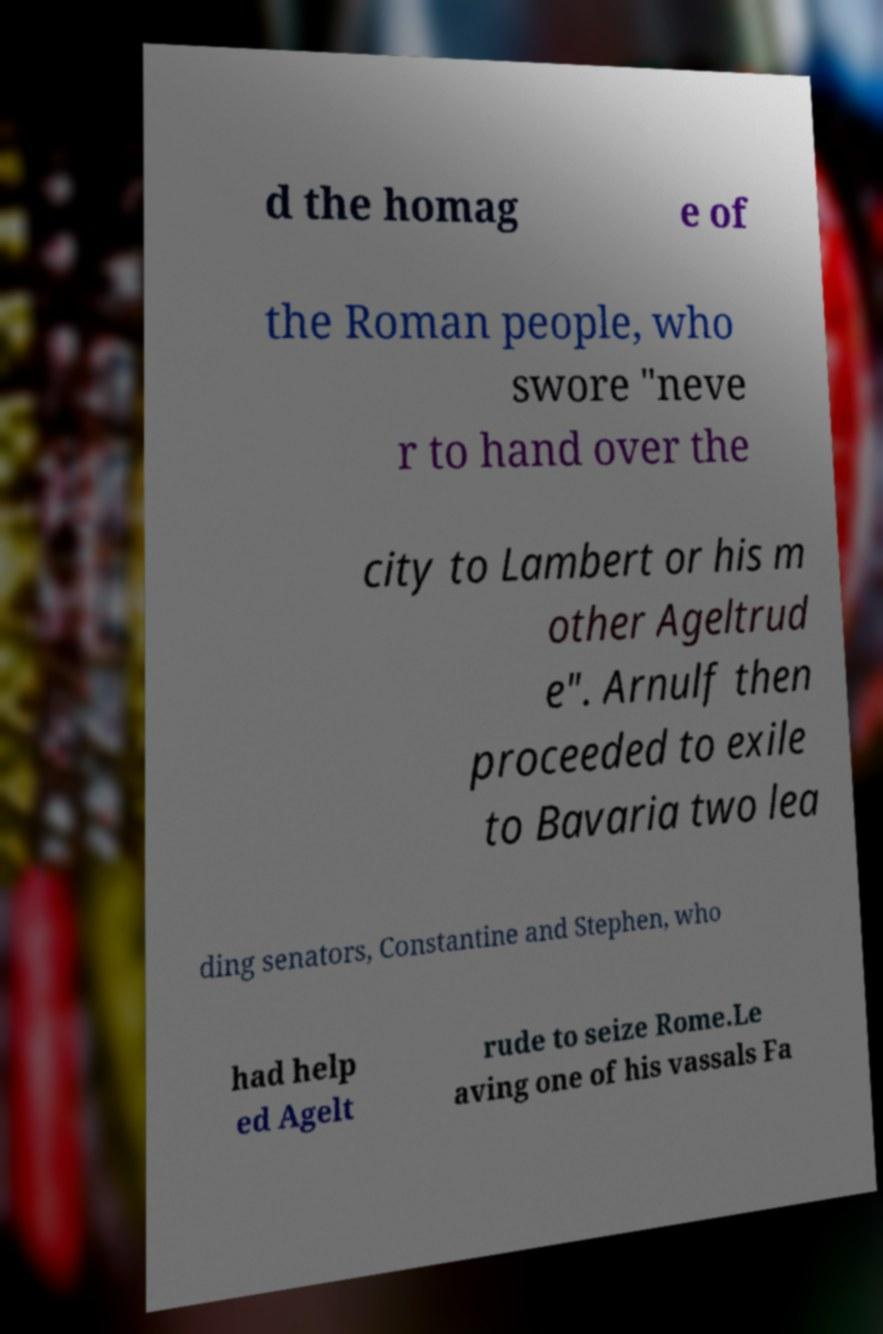Please read and relay the text visible in this image. What does it say? d the homag e of the Roman people, who swore "neve r to hand over the city to Lambert or his m other Ageltrud e". Arnulf then proceeded to exile to Bavaria two lea ding senators, Constantine and Stephen, who had help ed Agelt rude to seize Rome.Le aving one of his vassals Fa 